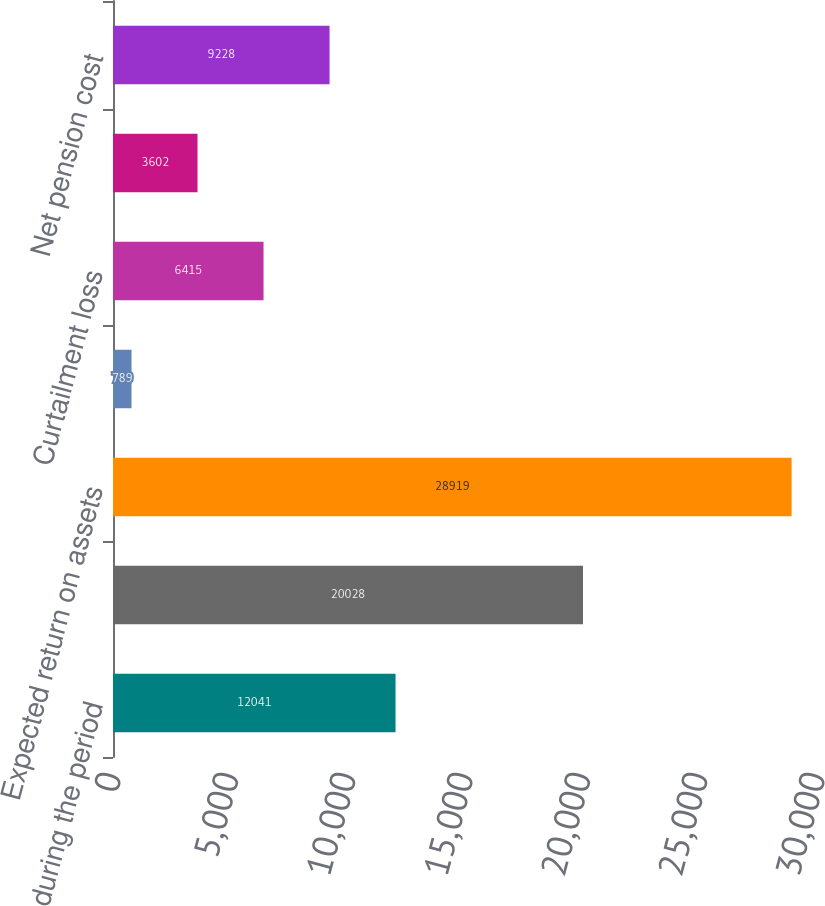Convert chart. <chart><loc_0><loc_0><loc_500><loc_500><bar_chart><fcel>during the period<fcel>benefit obligation<fcel>Expected return on assets<fcel>Amortization of prior service<fcel>Curtailment loss<fcel>Special termination benefits<fcel>Net pension cost<nl><fcel>12041<fcel>20028<fcel>28919<fcel>789<fcel>6415<fcel>3602<fcel>9228<nl></chart> 